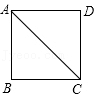What geometric properties can be derived from square ABCD besides the lengths of its sides and diagonals? In addition to side and diagonal measurements, square ABCD exhibits several key geometric properties. All interior angles are 90 degrees, indicating perpendicularity of adjacent sides. The diagonals AC and BD are congruent and bisect each other at right angles, which divides the square into four congruent right triangles. Furthermore, the diagonals also bisect the angles at the vertices, demonstrating symmetry and equal angular measures of 45 degrees at each division. 